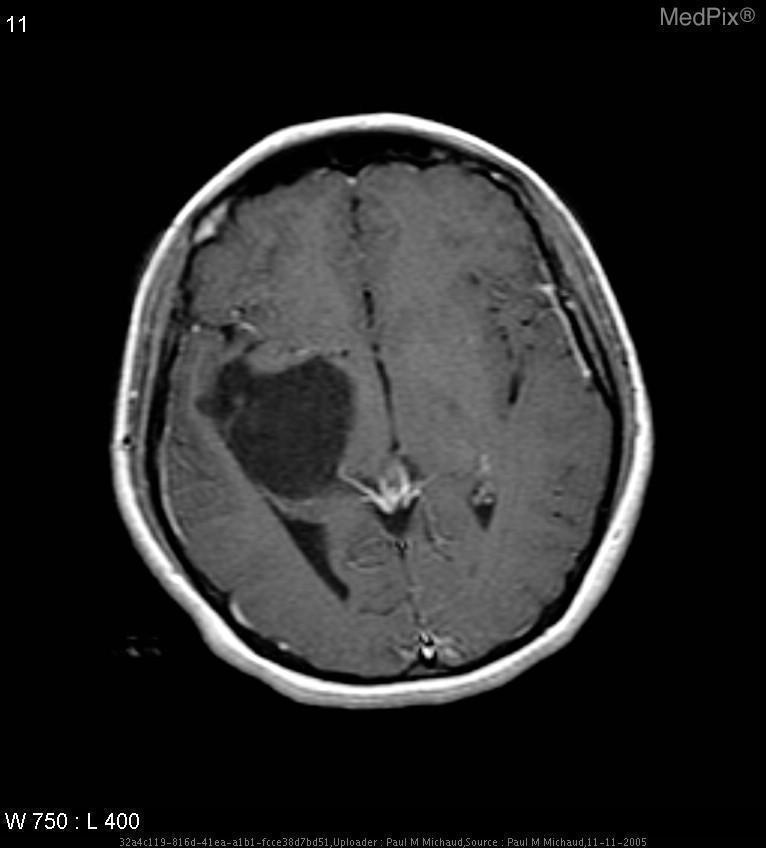Where is the mass?
Keep it brief. Extra-axial and at the right choroidal fissure. Is the mass enhancing?
Keep it brief. No. Is this image normal?
Concise answer only. No. 